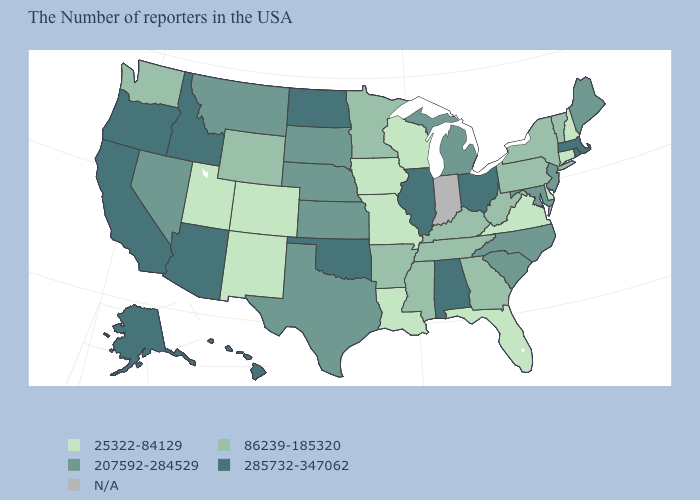Which states have the lowest value in the West?
Be succinct. Colorado, New Mexico, Utah. What is the value of Nevada?
Answer briefly. 207592-284529. What is the value of West Virginia?
Give a very brief answer. 86239-185320. Name the states that have a value in the range 285732-347062?
Keep it brief. Massachusetts, Rhode Island, Ohio, Alabama, Illinois, Oklahoma, North Dakota, Arizona, Idaho, California, Oregon, Alaska, Hawaii. Does the first symbol in the legend represent the smallest category?
Keep it brief. Yes. Is the legend a continuous bar?
Quick response, please. No. What is the value of Kansas?
Concise answer only. 207592-284529. Does Arizona have the lowest value in the West?
Keep it brief. No. Among the states that border Wyoming , does Montana have the lowest value?
Concise answer only. No. Is the legend a continuous bar?
Answer briefly. No. Name the states that have a value in the range 285732-347062?
Concise answer only. Massachusetts, Rhode Island, Ohio, Alabama, Illinois, Oklahoma, North Dakota, Arizona, Idaho, California, Oregon, Alaska, Hawaii. Does the map have missing data?
Concise answer only. Yes. What is the value of Tennessee?
Write a very short answer. 86239-185320. Among the states that border Arizona , does Utah have the highest value?
Keep it brief. No. 